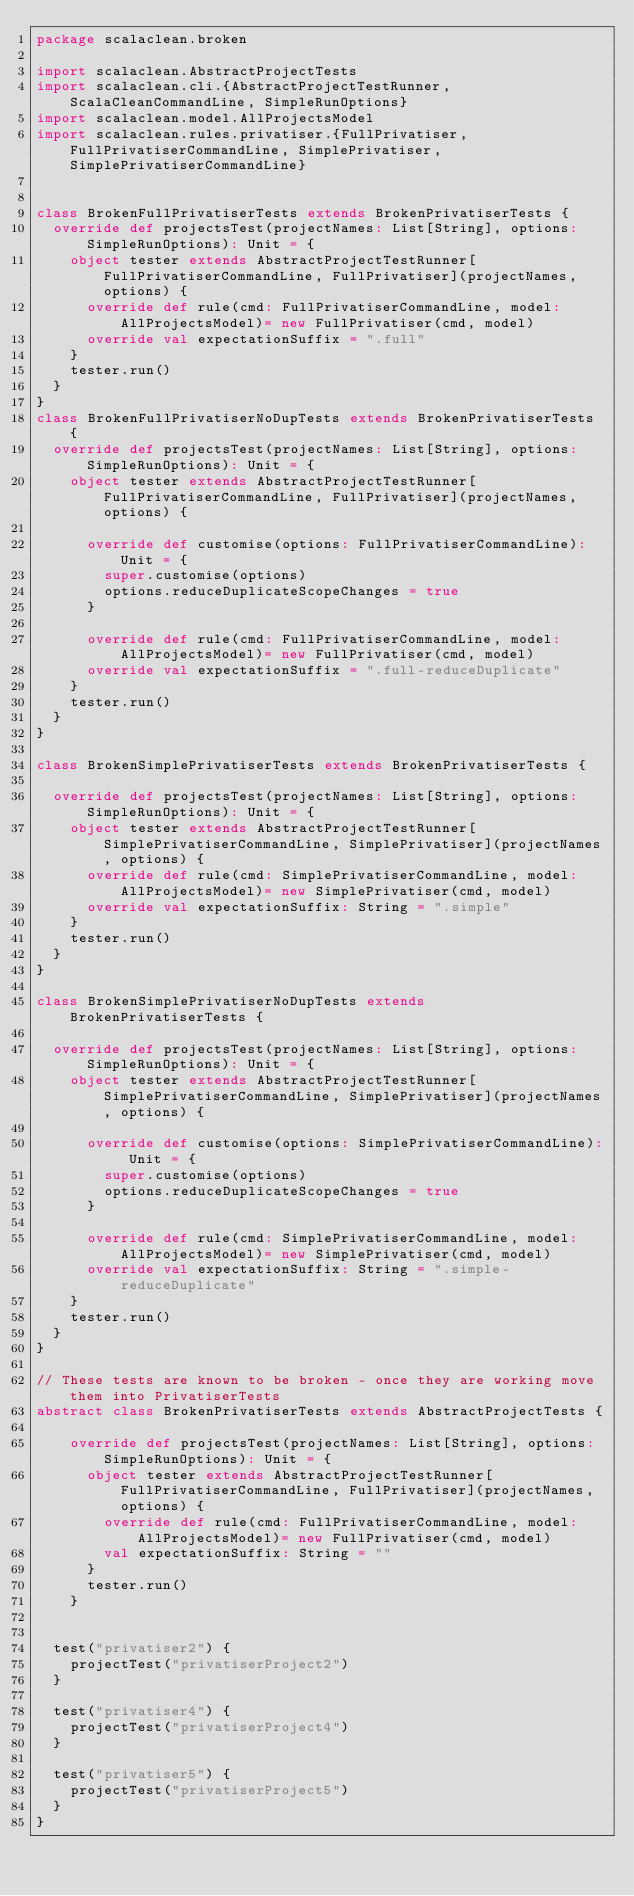<code> <loc_0><loc_0><loc_500><loc_500><_Scala_>package scalaclean.broken

import scalaclean.AbstractProjectTests
import scalaclean.cli.{AbstractProjectTestRunner, ScalaCleanCommandLine, SimpleRunOptions}
import scalaclean.model.AllProjectsModel
import scalaclean.rules.privatiser.{FullPrivatiser, FullPrivatiserCommandLine, SimplePrivatiser, SimplePrivatiserCommandLine}


class BrokenFullPrivatiserTests extends BrokenPrivatiserTests {
  override def projectsTest(projectNames: List[String], options: SimpleRunOptions): Unit = {
    object tester extends AbstractProjectTestRunner[FullPrivatiserCommandLine, FullPrivatiser](projectNames, options) {
      override def rule(cmd: FullPrivatiserCommandLine, model: AllProjectsModel)= new FullPrivatiser(cmd, model)
      override val expectationSuffix = ".full"
    }
    tester.run()
  }
}
class BrokenFullPrivatiserNoDupTests extends BrokenPrivatiserTests {
  override def projectsTest(projectNames: List[String], options: SimpleRunOptions): Unit = {
    object tester extends AbstractProjectTestRunner[FullPrivatiserCommandLine, FullPrivatiser](projectNames, options) {

      override def customise(options: FullPrivatiserCommandLine): Unit = {
        super.customise(options)
        options.reduceDuplicateScopeChanges = true
      }

      override def rule(cmd: FullPrivatiserCommandLine, model: AllProjectsModel)= new FullPrivatiser(cmd, model)
      override val expectationSuffix = ".full-reduceDuplicate"
    }
    tester.run()
  }
}

class BrokenSimplePrivatiserTests extends BrokenPrivatiserTests {

  override def projectsTest(projectNames: List[String], options: SimpleRunOptions): Unit = {
    object tester extends AbstractProjectTestRunner[SimplePrivatiserCommandLine, SimplePrivatiser](projectNames, options) {
      override def rule(cmd: SimplePrivatiserCommandLine, model: AllProjectsModel)= new SimplePrivatiser(cmd, model)
      override val expectationSuffix: String = ".simple"
    }
    tester.run()
  }
}

class BrokenSimplePrivatiserNoDupTests extends BrokenPrivatiserTests {

  override def projectsTest(projectNames: List[String], options: SimpleRunOptions): Unit = {
    object tester extends AbstractProjectTestRunner[SimplePrivatiserCommandLine, SimplePrivatiser](projectNames, options) {

      override def customise(options: SimplePrivatiserCommandLine): Unit = {
        super.customise(options)
        options.reduceDuplicateScopeChanges = true
      }

      override def rule(cmd: SimplePrivatiserCommandLine, model: AllProjectsModel)= new SimplePrivatiser(cmd, model)
      override val expectationSuffix: String = ".simple-reduceDuplicate"
    }
    tester.run()
  }
}

// These tests are known to be broken - once they are working move them into PrivatiserTests
abstract class BrokenPrivatiserTests extends AbstractProjectTests {

    override def projectsTest(projectNames: List[String], options: SimpleRunOptions): Unit = {
      object tester extends AbstractProjectTestRunner[FullPrivatiserCommandLine, FullPrivatiser](projectNames, options) {
        override def rule(cmd: FullPrivatiserCommandLine, model: AllProjectsModel)= new FullPrivatiser(cmd, model)
        val expectationSuffix: String = ""
      }
      tester.run()
    }


  test("privatiser2") {
    projectTest("privatiserProject2")
  }

  test("privatiser4") {
    projectTest("privatiserProject4")
  }

  test("privatiser5") {
    projectTest("privatiserProject5")
  }
}
</code> 